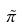<formula> <loc_0><loc_0><loc_500><loc_500>\tilde { \pi }</formula> 